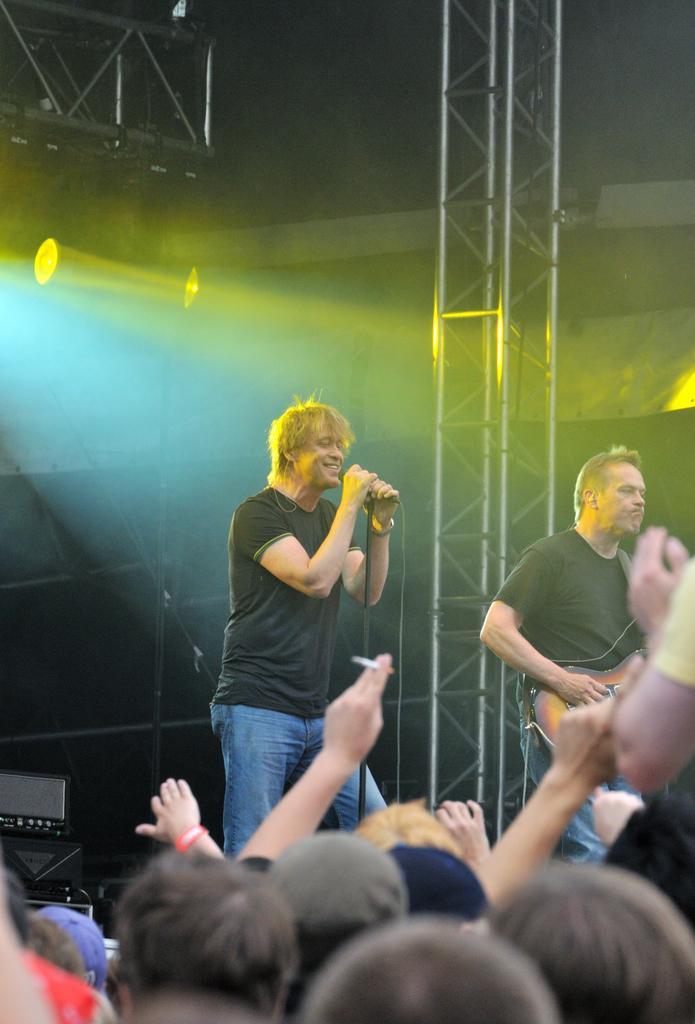Can you describe this image briefly? As we can see in the image there are lights, current pole, few people standing over here and on stage there are two people. The man on left side is holding guitar and this man is holding mic and singing a song. 